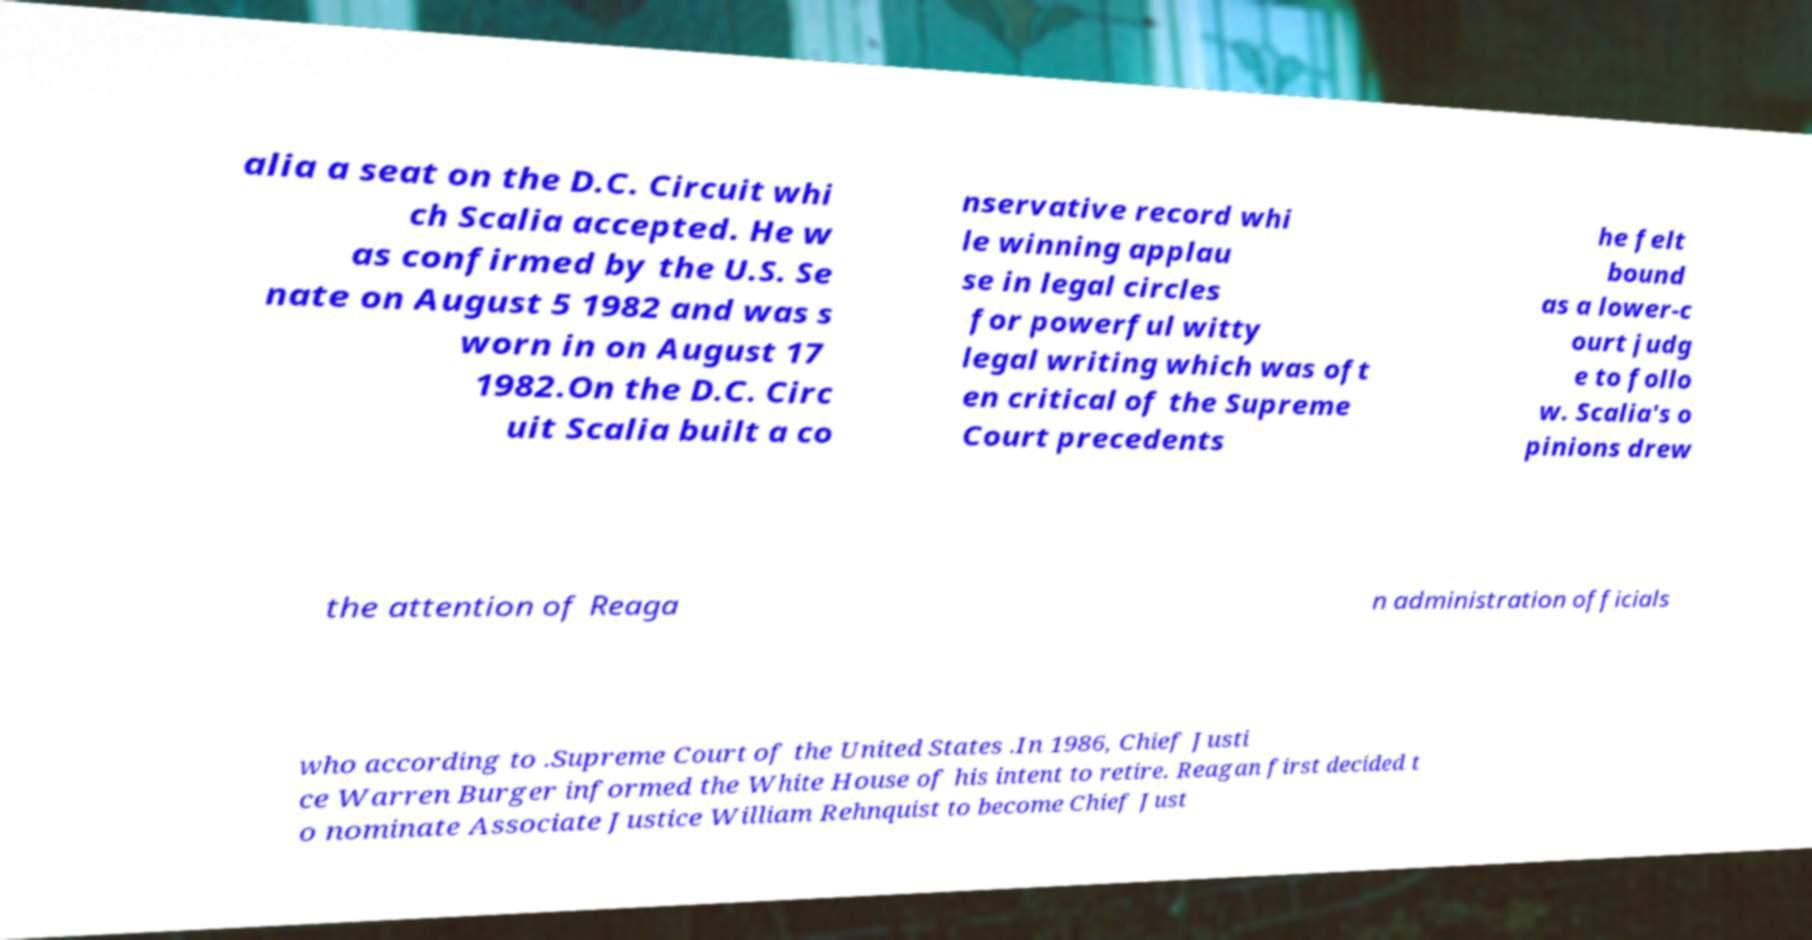There's text embedded in this image that I need extracted. Can you transcribe it verbatim? alia a seat on the D.C. Circuit whi ch Scalia accepted. He w as confirmed by the U.S. Se nate on August 5 1982 and was s worn in on August 17 1982.On the D.C. Circ uit Scalia built a co nservative record whi le winning applau se in legal circles for powerful witty legal writing which was oft en critical of the Supreme Court precedents he felt bound as a lower-c ourt judg e to follo w. Scalia's o pinions drew the attention of Reaga n administration officials who according to .Supreme Court of the United States .In 1986, Chief Justi ce Warren Burger informed the White House of his intent to retire. Reagan first decided t o nominate Associate Justice William Rehnquist to become Chief Just 